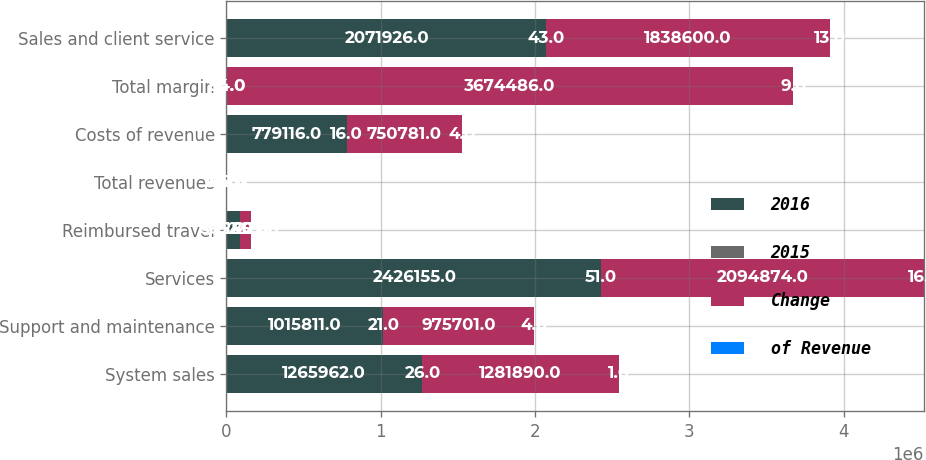Convert chart. <chart><loc_0><loc_0><loc_500><loc_500><stacked_bar_chart><ecel><fcel>System sales<fcel>Support and maintenance<fcel>Services<fcel>Reimbursed travel<fcel>Total revenues<fcel>Costs of revenue<fcel>Total margin<fcel>Sales and client service<nl><fcel>2016<fcel>1.26596e+06<fcel>1.01581e+06<fcel>2.42616e+06<fcel>88545<fcel>84<fcel>779116<fcel>84<fcel>2.07193e+06<nl><fcel>2015<fcel>26<fcel>21<fcel>51<fcel>2<fcel>100<fcel>16<fcel>84<fcel>43<nl><fcel>Change<fcel>1.28189e+06<fcel>975701<fcel>2.09487e+06<fcel>72802<fcel>84<fcel>750781<fcel>3.67449e+06<fcel>1.8386e+06<nl><fcel>of Revenue<fcel>1<fcel>4<fcel>16<fcel>22<fcel>8<fcel>4<fcel>9<fcel>13<nl></chart> 